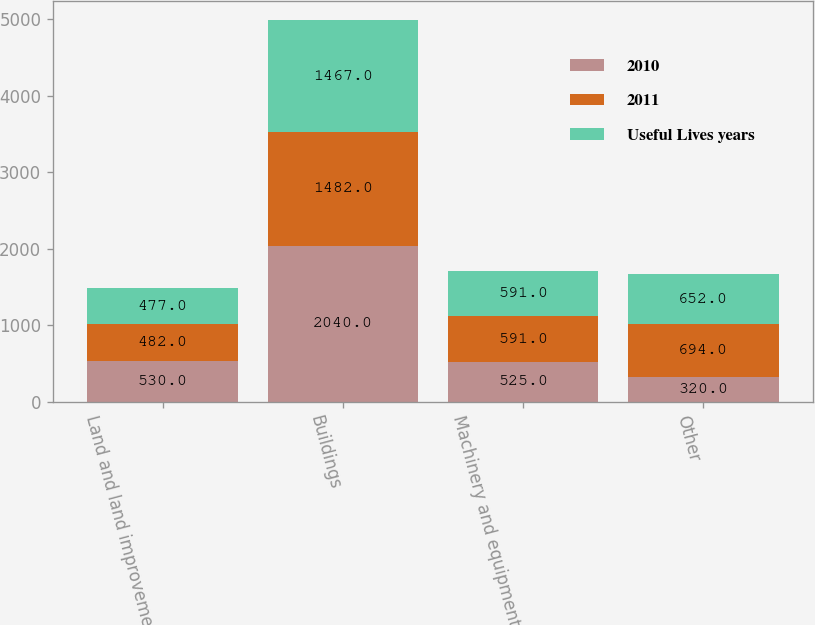Convert chart. <chart><loc_0><loc_0><loc_500><loc_500><stacked_bar_chart><ecel><fcel>Land and land improvements<fcel>Buildings<fcel>Machinery and equipment<fcel>Other<nl><fcel>2010<fcel>530<fcel>2040<fcel>525<fcel>320<nl><fcel>2011<fcel>482<fcel>1482<fcel>591<fcel>694<nl><fcel>Useful Lives years<fcel>477<fcel>1467<fcel>591<fcel>652<nl></chart> 